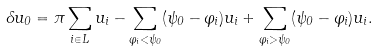<formula> <loc_0><loc_0><loc_500><loc_500>\Lambda u _ { 0 } = \pi \sum _ { i \in L } u _ { i } - \sum _ { \varphi _ { i } < \psi _ { 0 } } ( \psi _ { 0 } - \varphi _ { i } ) u _ { i } + \sum _ { \varphi _ { i } > \psi _ { 0 } } ( \psi _ { 0 } - \varphi _ { i } ) u _ { i } .</formula> 